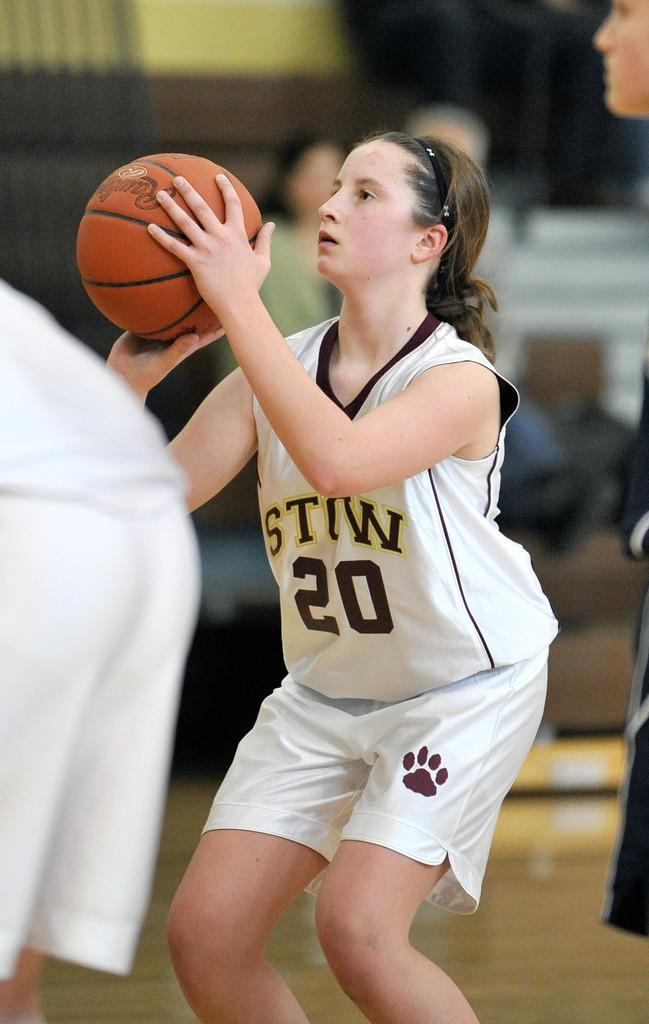<image>
Offer a succinct explanation of the picture presented. A girl is ready to shoot a basketball, her uniform has the number 20 on it. 